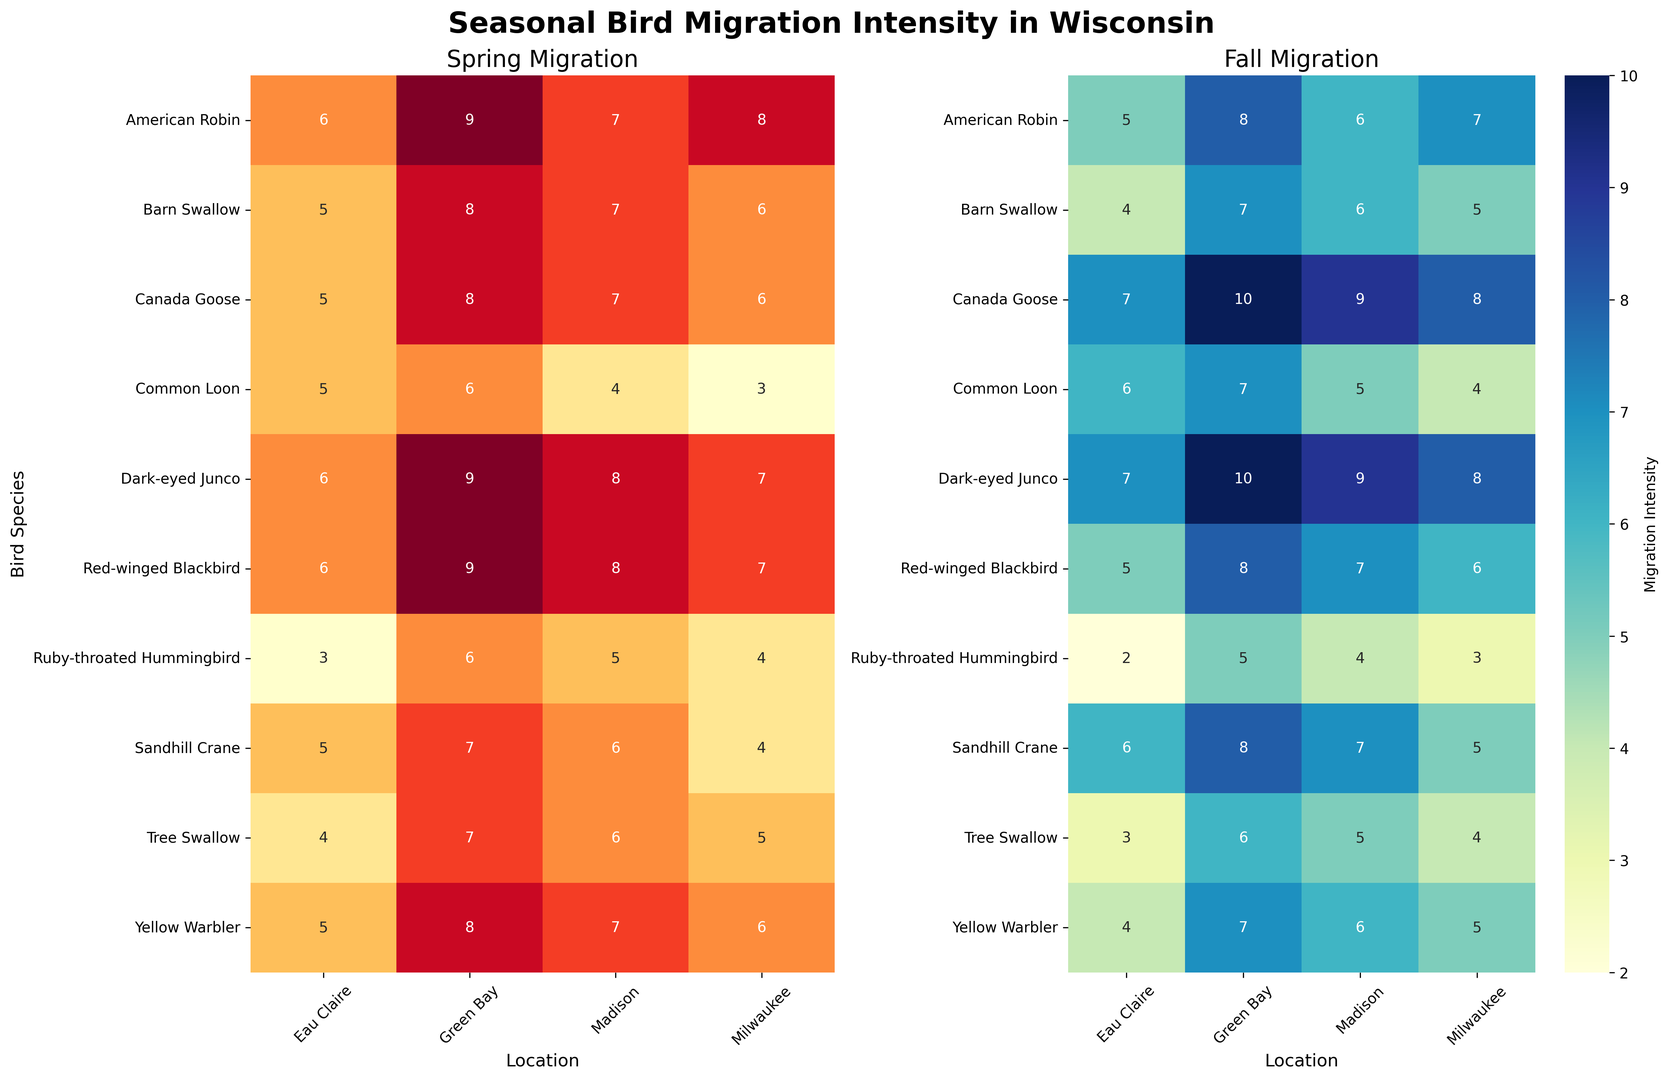what species has the highest spring migration intensity in Green Bay? To find the answer, look at the 'Spring Migration' heatmap and identify the cell in the 'Green Bay' column with the highest intensity value. It corresponds to the species "American Robin" with an intensity of 9.
Answer: American Robin Which species shows greater migration intensity in Fall compared to Spring in Madison? Compare the migration intensity values for each species in the 'Spring Migration' and 'Fall Migration' heatmaps for the 'Madison' column. For "Canada Goose" and "Dark-eyed Junco", the fall intensity is greater.
Answer: Canada Goose, Dark-eyed Junco What is the average fall migration intensity of Yellow Warbler across all locations? To find the average, sum the fall migration intensity values for Yellow Warbler across all locations (5+6+7+4 = 22) and then divide by the number of locations (4).
Answer: 5.5 Which location has the highest overall migration intensity (sum of Spring and Fall) for the Canada Goose? For each location, sum the spring and fall migration intensities: Milwaukee (6+8=14), Madison (7+9=16), Green Bay (8+10=18), Eau Claire (5+7=12). Green Bay has the highest total.
Answer: Green Bay Compare the spring migration intensity of Tree Swallow in Milwaukee and Green Bay. Which location has a higher value? Look at the 'Spring Migration' heatmap and compare the values for Tree Swallow in 'Milwaukee' (5) and 'Green Bay' (7). Green Bay has a higher value.
Answer: Green Bay Which season shows higher average migration intensity for the American Robin in Eau Claire, and what is the difference between the two intensities? Compare the migration intensities for the American Robin in Eau Claire: Spring (6) and Fall (5). To find the difference, subtract the fall intensity from the spring intensity (6 - 5).
Answer: Spring, 1 Identify the species with the lowest fall migration intensity in Eau Claire. In the 'Fall Migration' heatmap, find the species with the lowest value in the 'Eau Claire' column. "Ruby-throated Hummingbird" has the lowest value of 2.
Answer: Ruby-throated Hummingbird What is the overall average spring migration intensity for all species in Milwaukee? Sum the spring migration intensities for all species in Milwaukee (8+6+4+7+5+6+3+4+6+7 = 56) and divide by the number of species (10).
Answer: 5.6 Which species has similar migration intensity patterns across both seasons in Madison? Identify species with nearly equal values for both seasons in Madison. "Yellow Warbler" (7 in Spring, 6 in Fall) and "Barn Swallow" (7 in Spring, 6 in Fall) are examples.
Answer: Yellow Warbler, Barn Swallow 